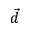Convert formula to latex. <formula><loc_0><loc_0><loc_500><loc_500>\vec { d }</formula> 